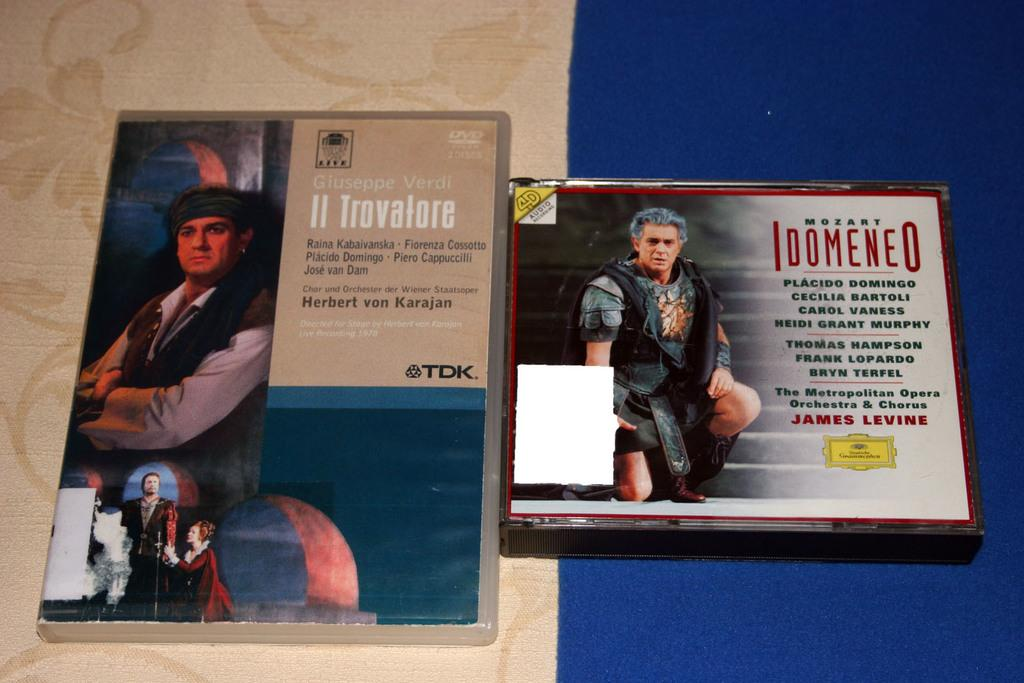<image>
Summarize the visual content of the image. An Idomeneo CD has a man wearing a Roman costume on the cover. 